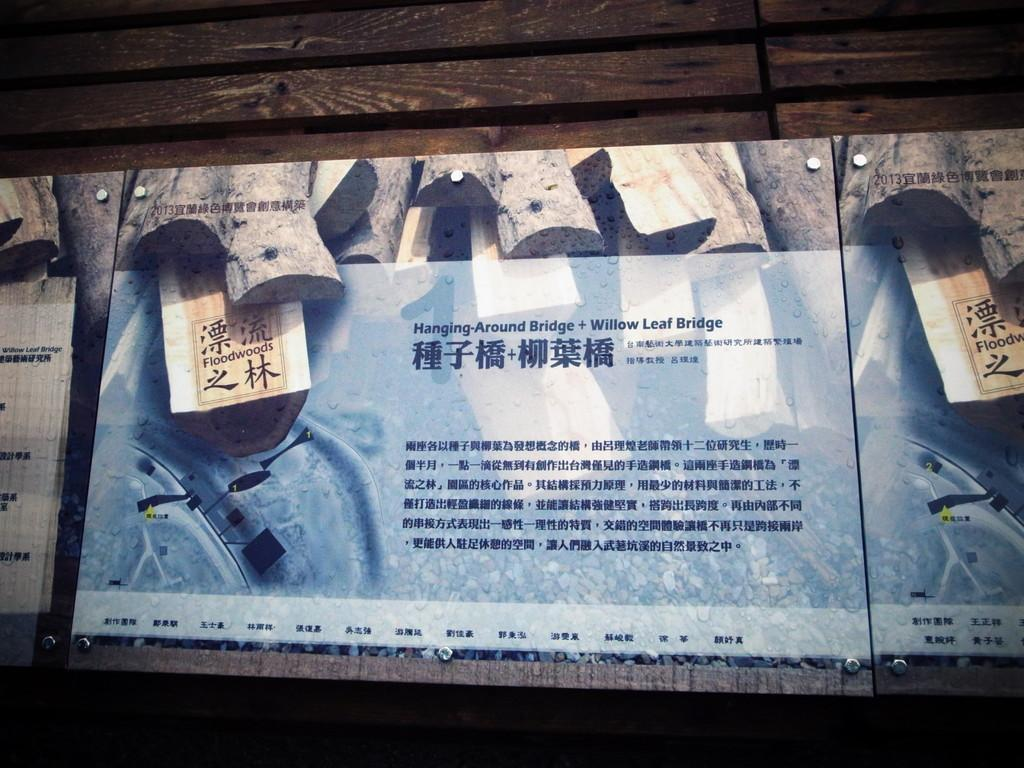What is featured in the frames in the image? There are frames with words in the image. What else can be seen inside the frames? There are photos in the frames. How are the frames arranged or connected in the image? The frames are attached to a wooden board. How many clocks are visible in the image? There are no clocks visible in the image; it features frames with words and photos attached to a wooden board. What type of material is the silver used for in the image? There is no silver present in the image. Are there any books visible in the image? There are no books visible in the image; it features frames with words and photos attached to a wooden board. 